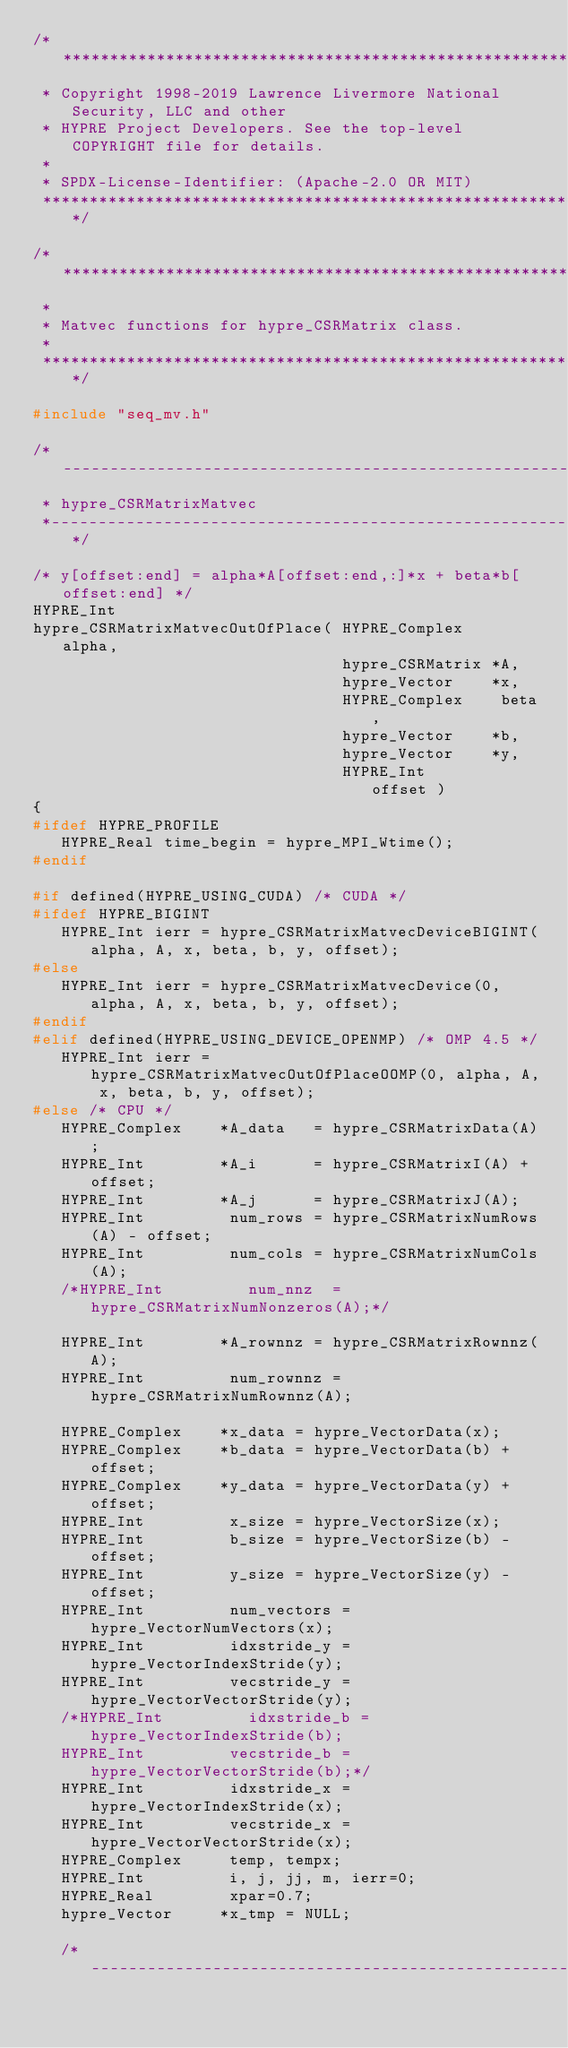<code> <loc_0><loc_0><loc_500><loc_500><_C_>/******************************************************************************
 * Copyright 1998-2019 Lawrence Livermore National Security, LLC and other
 * HYPRE Project Developers. See the top-level COPYRIGHT file for details.
 *
 * SPDX-License-Identifier: (Apache-2.0 OR MIT)
 ******************************************************************************/

/******************************************************************************
 *
 * Matvec functions for hypre_CSRMatrix class.
 *
 *****************************************************************************/

#include "seq_mv.h"

/*--------------------------------------------------------------------------
 * hypre_CSRMatrixMatvec
 *--------------------------------------------------------------------------*/

/* y[offset:end] = alpha*A[offset:end,:]*x + beta*b[offset:end] */
HYPRE_Int
hypre_CSRMatrixMatvecOutOfPlace( HYPRE_Complex    alpha,
                                 hypre_CSRMatrix *A,
                                 hypre_Vector    *x,
                                 HYPRE_Complex    beta,
                                 hypre_Vector    *b,
                                 hypre_Vector    *y,
                                 HYPRE_Int        offset )
{
#ifdef HYPRE_PROFILE
   HYPRE_Real time_begin = hypre_MPI_Wtime();
#endif

#if defined(HYPRE_USING_CUDA) /* CUDA */
#ifdef HYPRE_BIGINT
   HYPRE_Int ierr = hypre_CSRMatrixMatvecDeviceBIGINT(alpha, A, x, beta, b, y, offset);
#else
   HYPRE_Int ierr = hypre_CSRMatrixMatvecDevice(0, alpha, A, x, beta, b, y, offset);
#endif
#elif defined(HYPRE_USING_DEVICE_OPENMP) /* OMP 4.5 */
   HYPRE_Int ierr = hypre_CSRMatrixMatvecOutOfPlaceOOMP(0, alpha, A, x, beta, b, y, offset);
#else /* CPU */
   HYPRE_Complex    *A_data   = hypre_CSRMatrixData(A);
   HYPRE_Int        *A_i      = hypre_CSRMatrixI(A) + offset;
   HYPRE_Int        *A_j      = hypre_CSRMatrixJ(A);
   HYPRE_Int         num_rows = hypre_CSRMatrixNumRows(A) - offset;
   HYPRE_Int         num_cols = hypre_CSRMatrixNumCols(A);
   /*HYPRE_Int         num_nnz  = hypre_CSRMatrixNumNonzeros(A);*/

   HYPRE_Int        *A_rownnz = hypre_CSRMatrixRownnz(A);
   HYPRE_Int         num_rownnz = hypre_CSRMatrixNumRownnz(A);

   HYPRE_Complex    *x_data = hypre_VectorData(x);
   HYPRE_Complex    *b_data = hypre_VectorData(b) + offset;
   HYPRE_Complex    *y_data = hypre_VectorData(y) + offset;
   HYPRE_Int         x_size = hypre_VectorSize(x);
   HYPRE_Int         b_size = hypre_VectorSize(b) - offset;
   HYPRE_Int         y_size = hypre_VectorSize(y) - offset;
   HYPRE_Int         num_vectors = hypre_VectorNumVectors(x);
   HYPRE_Int         idxstride_y = hypre_VectorIndexStride(y);
   HYPRE_Int         vecstride_y = hypre_VectorVectorStride(y);
   /*HYPRE_Int         idxstride_b = hypre_VectorIndexStride(b);
   HYPRE_Int         vecstride_b = hypre_VectorVectorStride(b);*/
   HYPRE_Int         idxstride_x = hypre_VectorIndexStride(x);
   HYPRE_Int         vecstride_x = hypre_VectorVectorStride(x);
   HYPRE_Complex     temp, tempx;
   HYPRE_Int         i, j, jj, m, ierr=0;
   HYPRE_Real        xpar=0.7;
   hypre_Vector     *x_tmp = NULL;

   /*---------------------------------------------------------------------</code> 